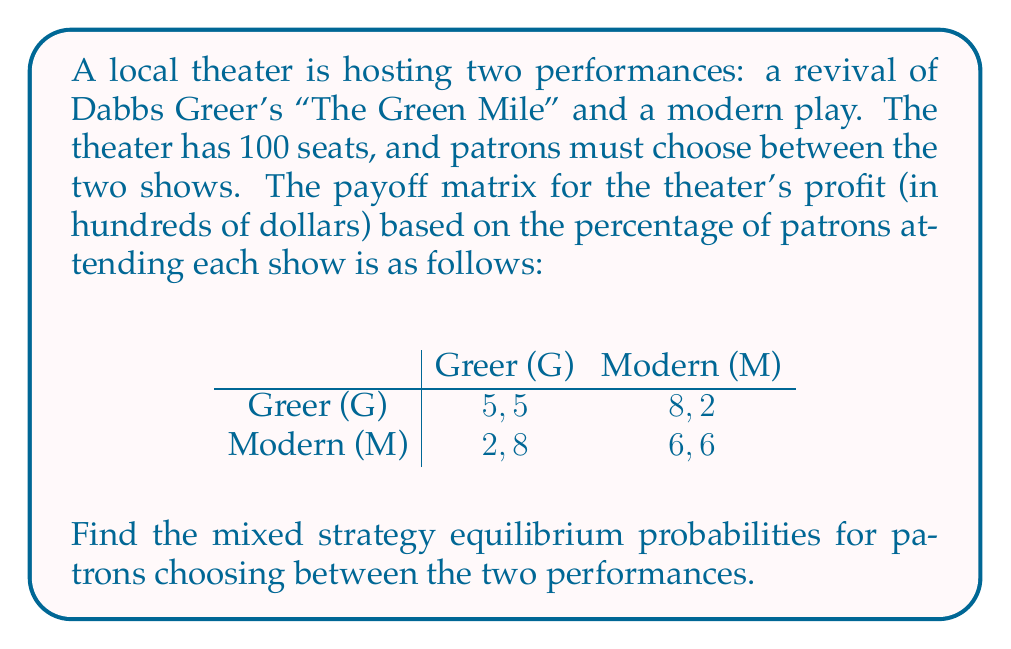Could you help me with this problem? To find the mixed strategy equilibrium, we need to follow these steps:

1) Let $p$ be the probability of choosing Greer's play, and $(1-p)$ be the probability of choosing the modern play.

2) For a mixed strategy equilibrium, the expected payoff for choosing either option must be equal. Let's set up the equation:

   $5p + 8(1-p) = 2p + 6(1-p)$

3) Simplify the equation:
   $5p + 8 - 8p = 2p + 6 - 6p$
   $-3p + 8 = -4p + 6$

4) Solve for $p$:
   $p = 2/7 \approx 0.2857$

5) The probability of choosing the modern play is $(1-p) = 5/7 \approx 0.7143$

6) Verify that these probabilities make the payoffs equal:
   For Greer: $5(2/7) + 8(5/7) = 10/7 + 40/7 = 50/7$
   For Modern: $2(2/7) + 6(5/7) = 4/7 + 30/7 = 34/7$

   Both equal $50/7 \approx 7.14$, confirming our solution.
Answer: Greer: $p = 2/7 \approx 0.2857$, Modern: $1-p = 5/7 \approx 0.7143$ 